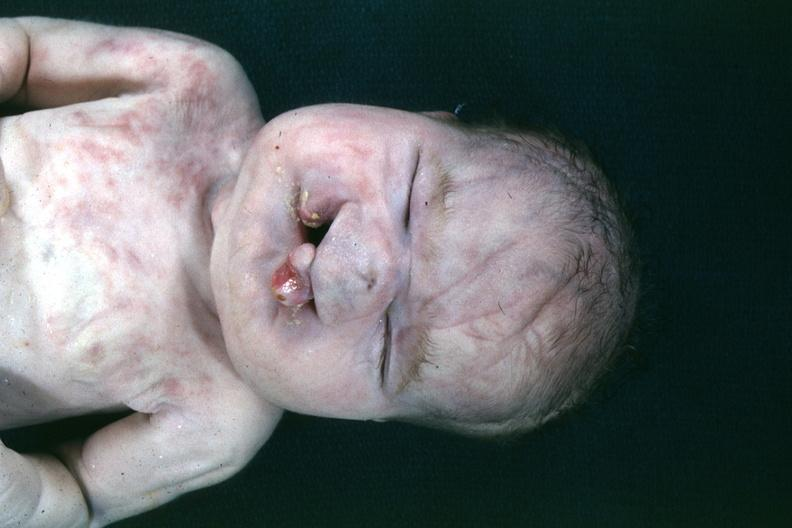what is present?
Answer the question using a single word or phrase. Bilateral cleft palate 